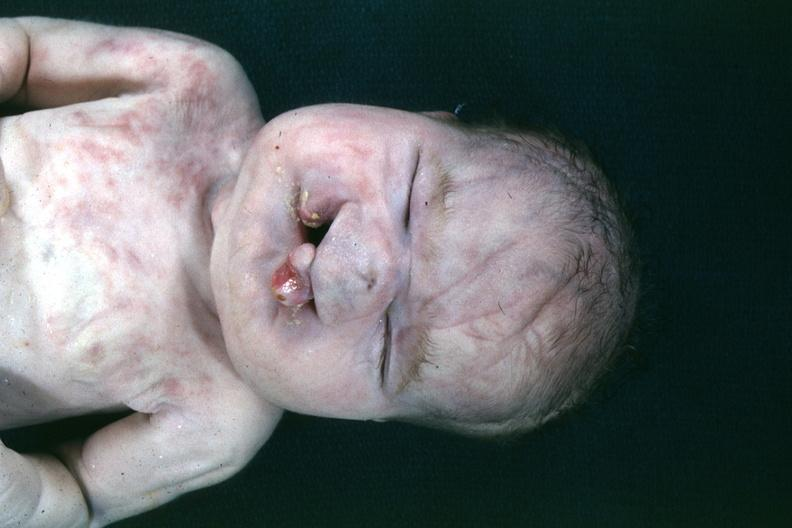what is present?
Answer the question using a single word or phrase. Bilateral cleft palate 